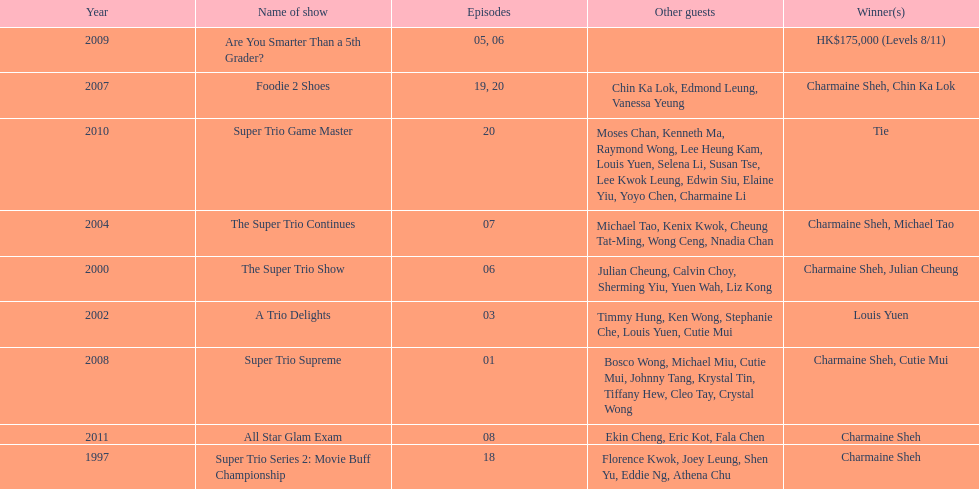What is the number of tv shows that charmaine sheh has appeared on? 9. 